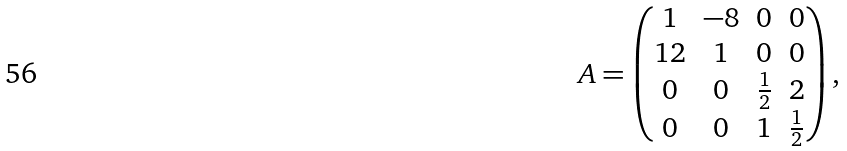<formula> <loc_0><loc_0><loc_500><loc_500>A = \begin{pmatrix} 1 & - 8 & 0 & 0 \\ 1 2 & 1 & 0 & 0 \\ 0 & 0 & \frac { 1 } { 2 } & 2 \\ 0 & 0 & 1 & \frac { 1 } { 2 } \end{pmatrix} ,</formula> 